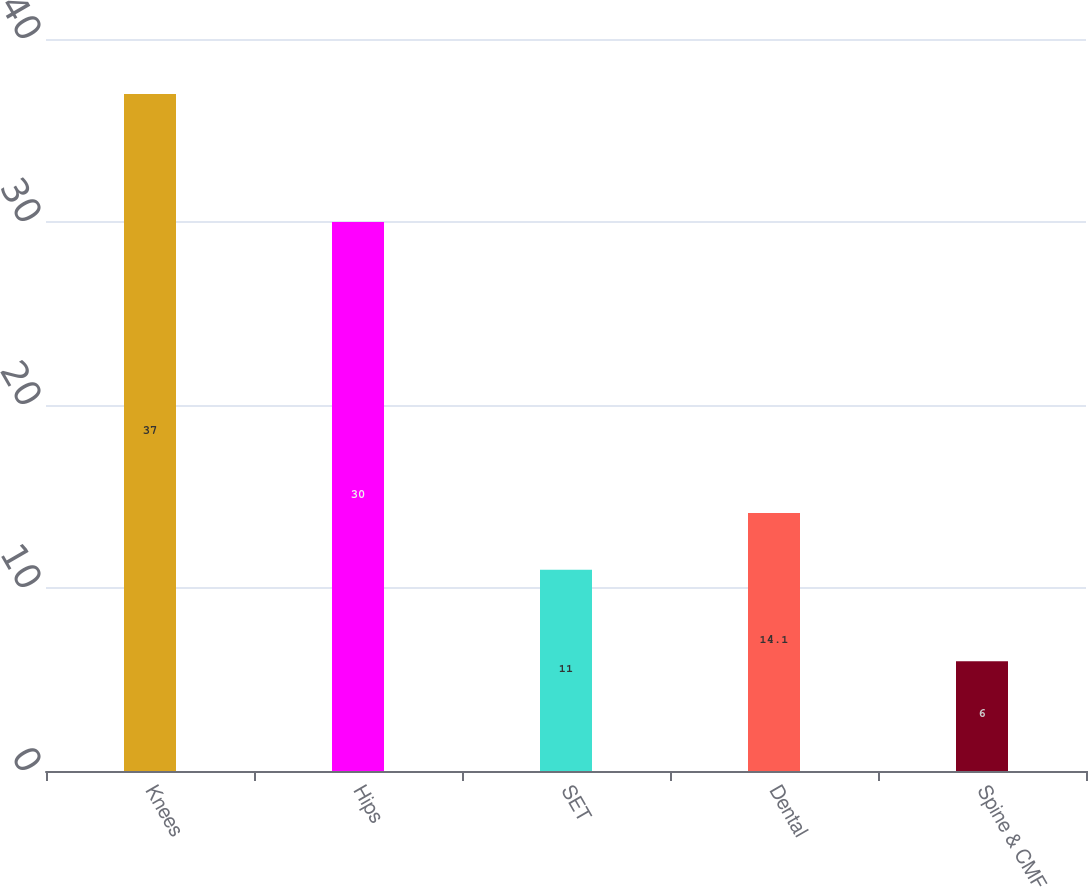<chart> <loc_0><loc_0><loc_500><loc_500><bar_chart><fcel>Knees<fcel>Hips<fcel>SET<fcel>Dental<fcel>Spine & CMF<nl><fcel>37<fcel>30<fcel>11<fcel>14.1<fcel>6<nl></chart> 